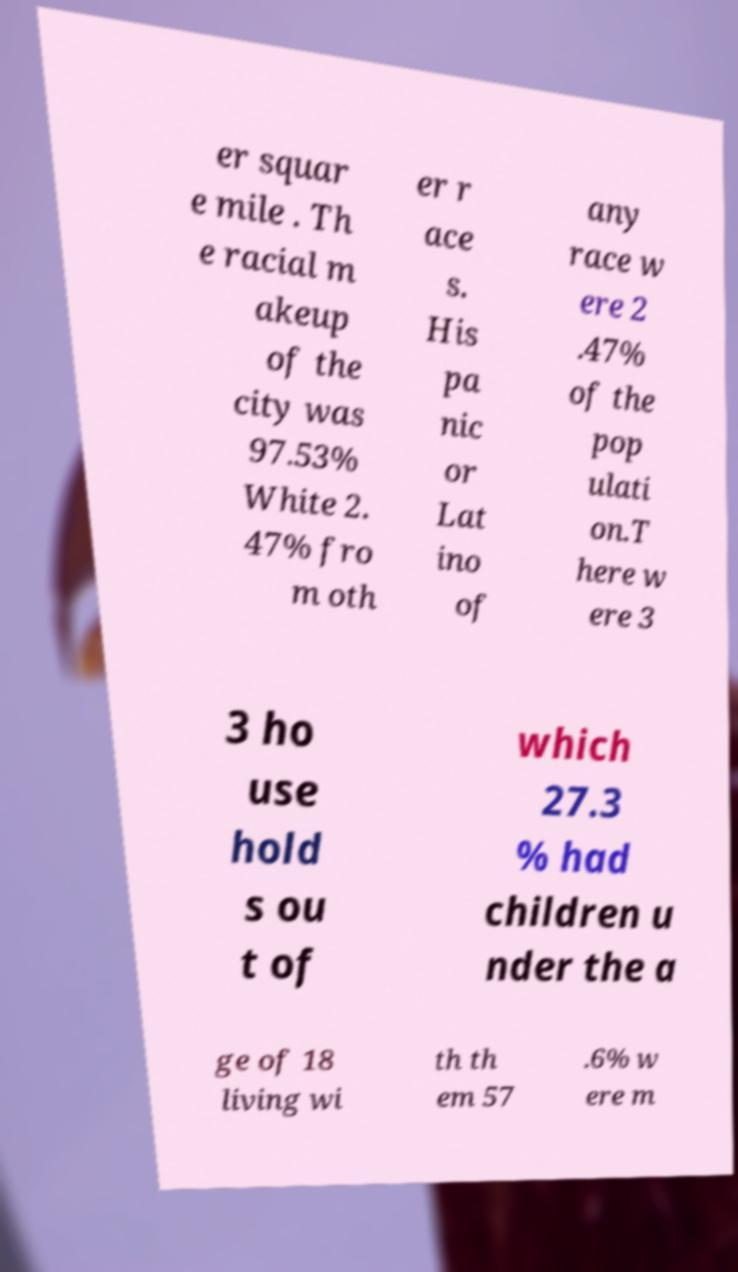Please identify and transcribe the text found in this image. er squar e mile . Th e racial m akeup of the city was 97.53% White 2. 47% fro m oth er r ace s. His pa nic or Lat ino of any race w ere 2 .47% of the pop ulati on.T here w ere 3 3 ho use hold s ou t of which 27.3 % had children u nder the a ge of 18 living wi th th em 57 .6% w ere m 